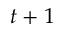Convert formula to latex. <formula><loc_0><loc_0><loc_500><loc_500>t + 1</formula> 